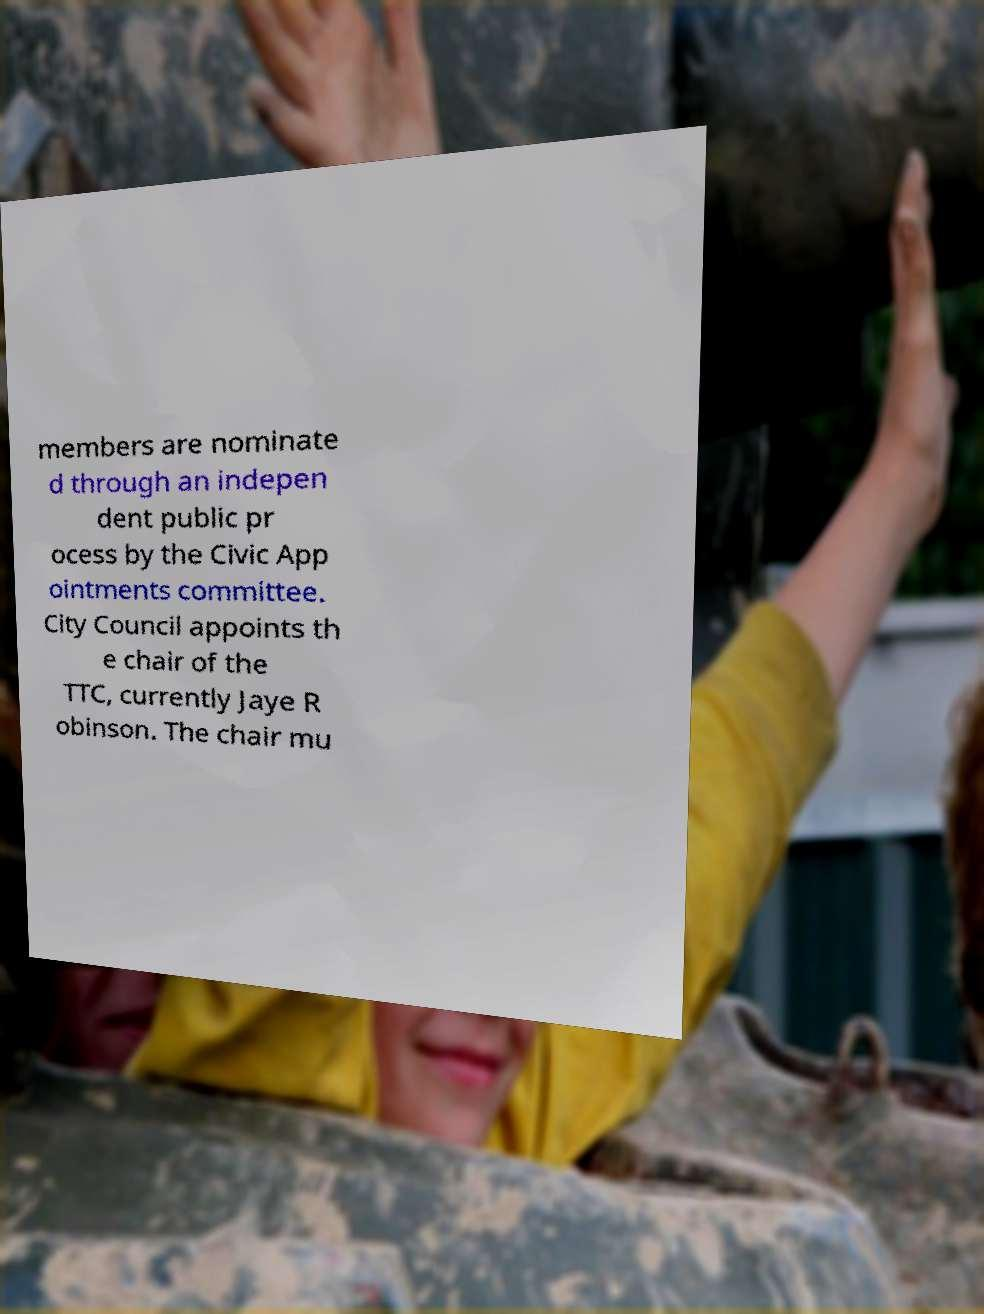I need the written content from this picture converted into text. Can you do that? members are nominate d through an indepen dent public pr ocess by the Civic App ointments committee. City Council appoints th e chair of the TTC, currently Jaye R obinson. The chair mu 